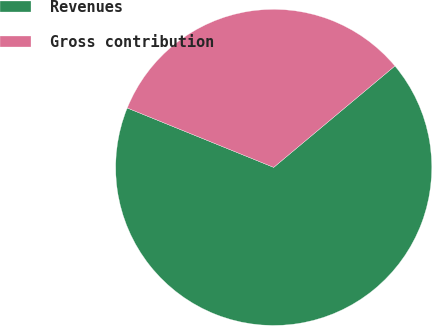Convert chart to OTSL. <chart><loc_0><loc_0><loc_500><loc_500><pie_chart><fcel>Revenues<fcel>Gross contribution<nl><fcel>67.22%<fcel>32.78%<nl></chart> 